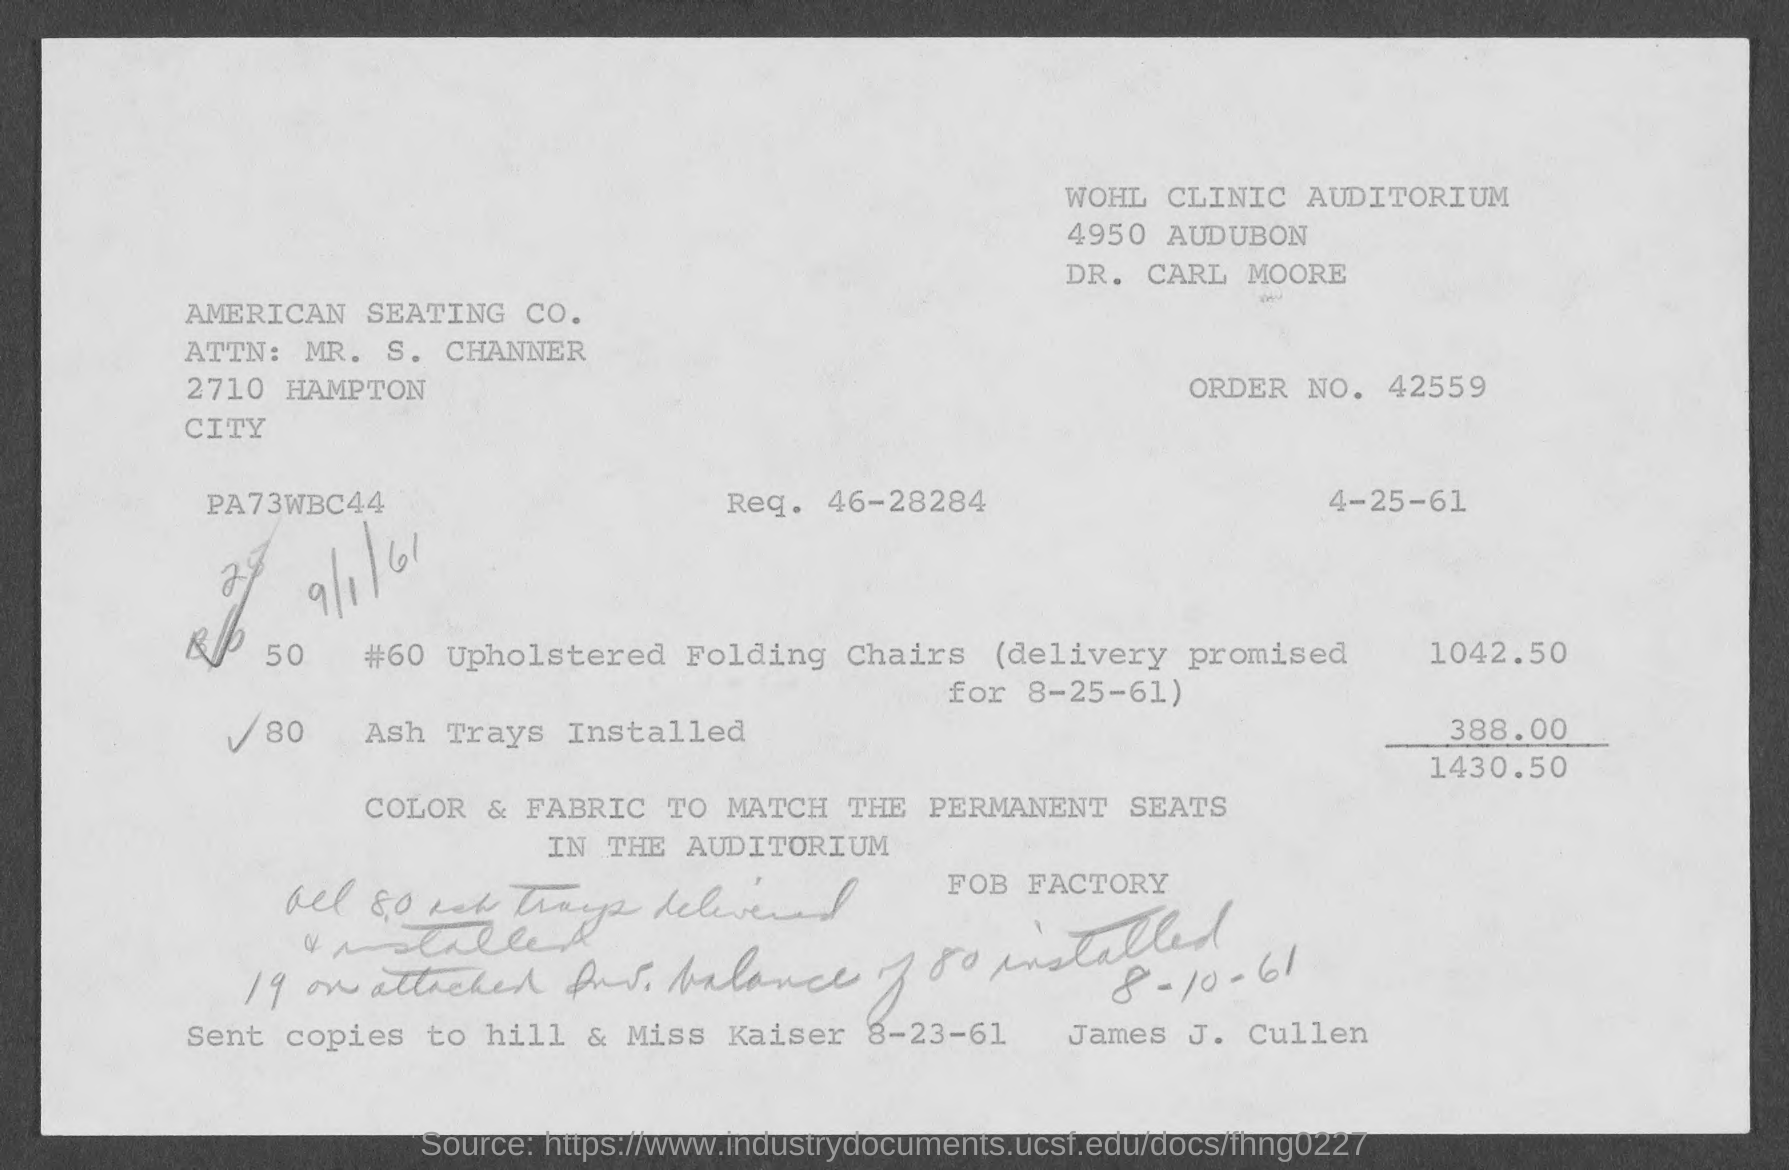Identify some key points in this picture. The order number is 42559. The question "what is req. no. 46-28284?" is asking for information about a request number. 